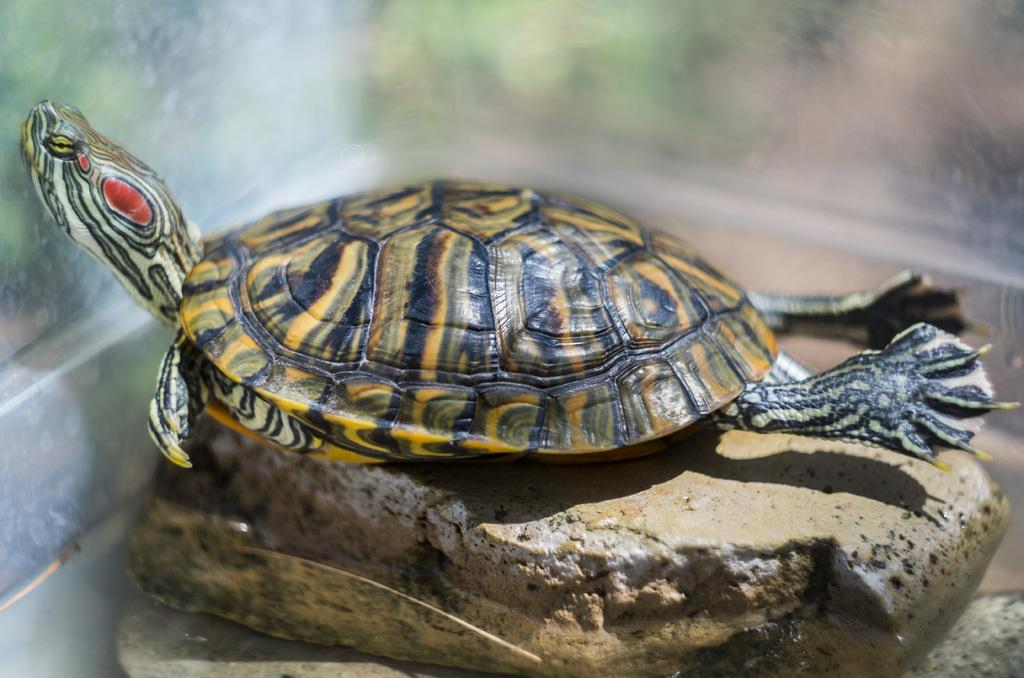What animal is present in the image? There is a turtle in the image. What is the turtle resting on? The turtle is on a stone. Can you describe the background of the image? The background of the image is blurry. What color is the toy in the image? There is no toy present in the image; it only features a turtle on a stone with a blurry background. 